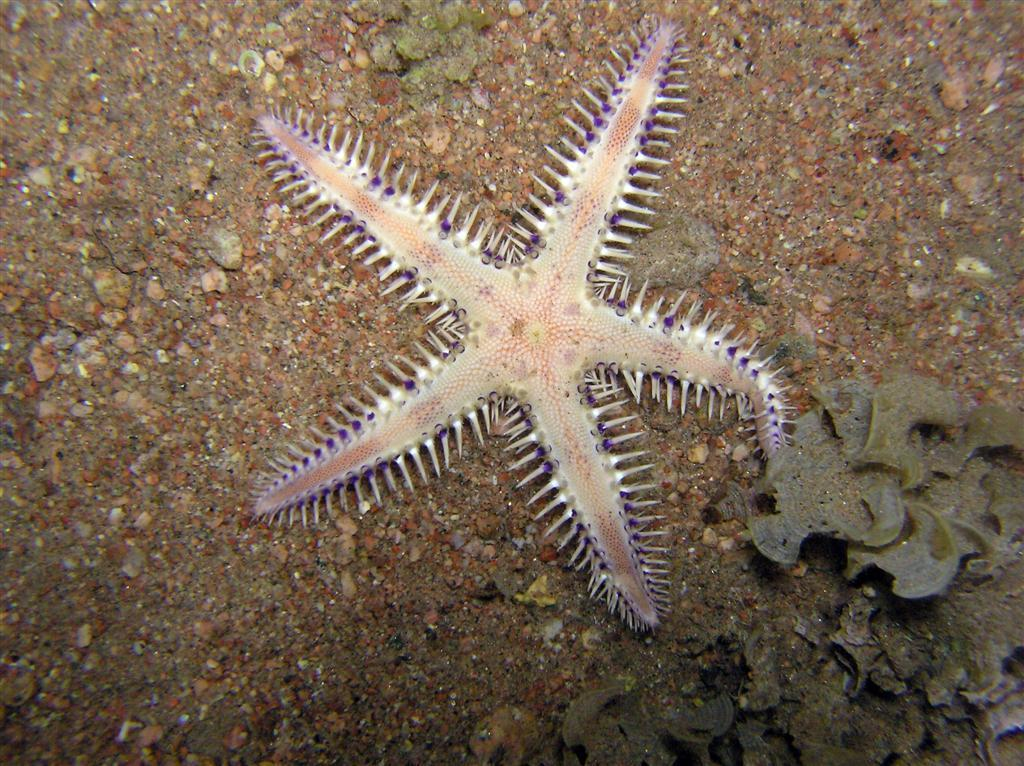What type of marine animal is in the image? There is a starfish in the image. What can be seen on the ground in the image? There are stones on the ground in the image. Can you describe any other elements in the image? There are other unspecified elements in the image. What type of meat is being prepared in the image? There is no meat present in the image; it features a starfish and stones on the ground. Can you read any writing on the stones in the image? There is no writing visible on the stones in the image. 